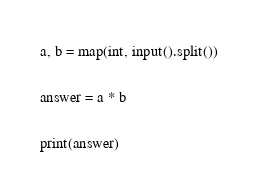<code> <loc_0><loc_0><loc_500><loc_500><_Python_>a, b = map(int, input().split())

answer = a * b

print(answer)</code> 